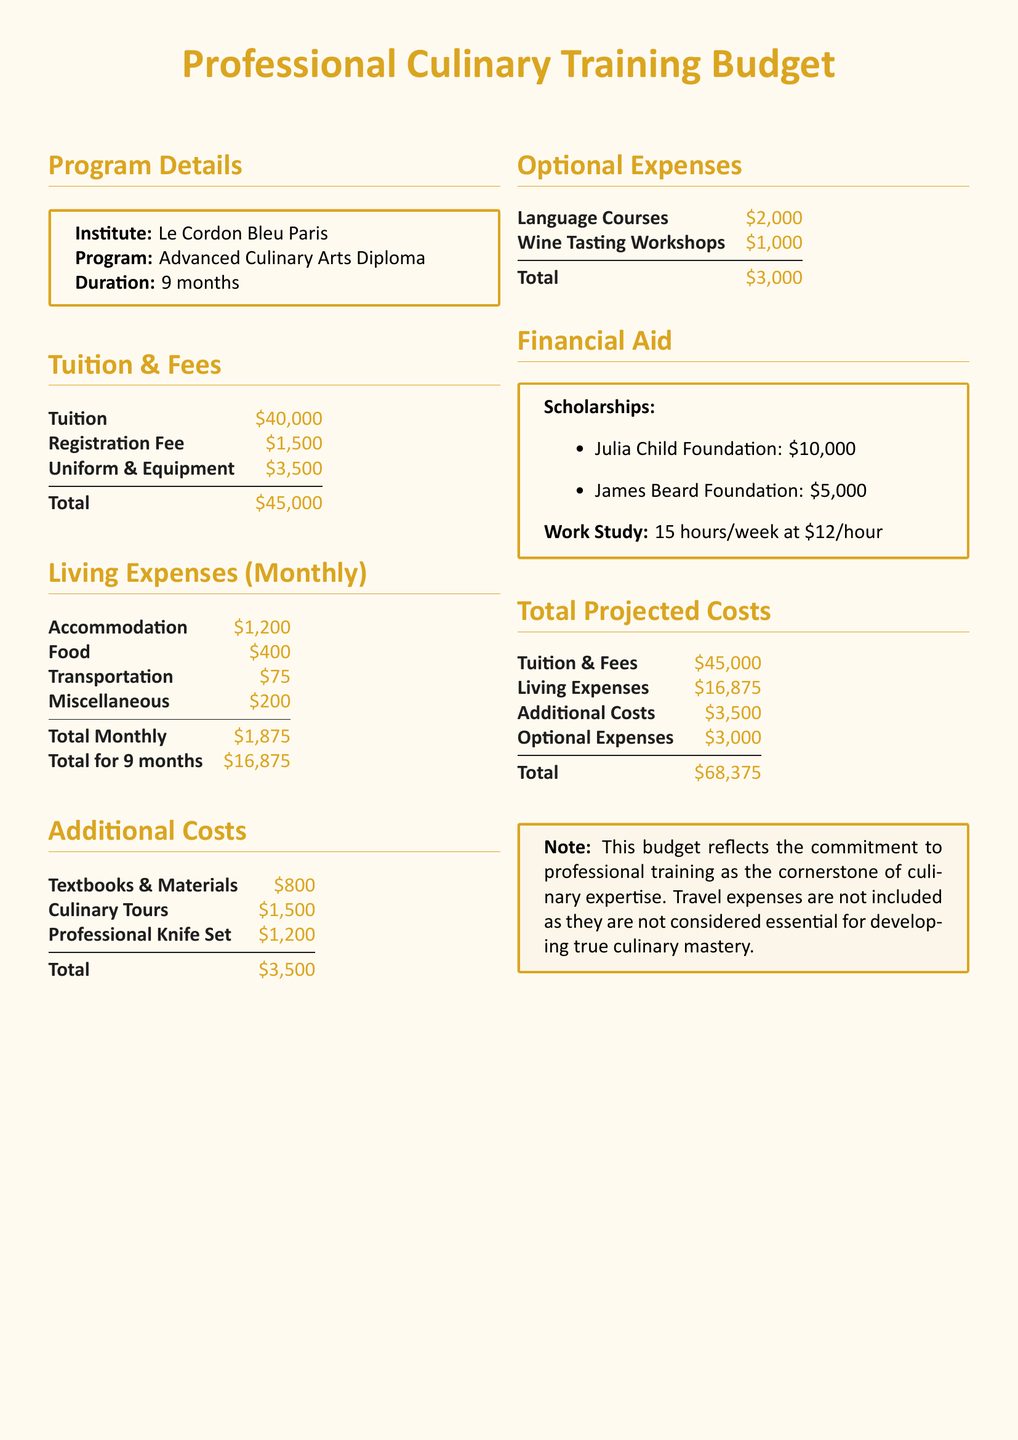What is the total tuition cost? The tuition cost is explicitly stated in the document as $40,000.
Answer: $40,000 What is the total for living expenses over 9 months? The document includes a section that calculates the living expenses total for 9 months as $16,875.
Answer: $16,875 What is the total projected cost for the program? The total projected cost is summarised at the end of the document as $68,375, which includes tuition, living expenses, additional costs, and optional expenses.
Answer: $68,375 Which institute is offering the advanced training program? The institute offering the program is Le Cordon Bleu Paris, clearly stated in the program details section.
Answer: Le Cordon Bleu Paris What is the amount of the Julia Child Foundation scholarship? The budget lists the Julia Child Foundation scholarship amount as $10,000.
Answer: $10,000 What is included in additional costs? The additional costs section lists textbooks & materials, culinary tours, and a professional knife set as the included items.
Answer: Textbooks & Materials, Culinary Tours, Professional Knife Set What is the monthly accommodation expense? The document specifies the monthly accommodation expense as $1,200 under living expenses.
Answer: $1,200 How many hours per week is the work study? The work study is stated to be for 15 hours per week in the financial aid section.
Answer: 15 hours 